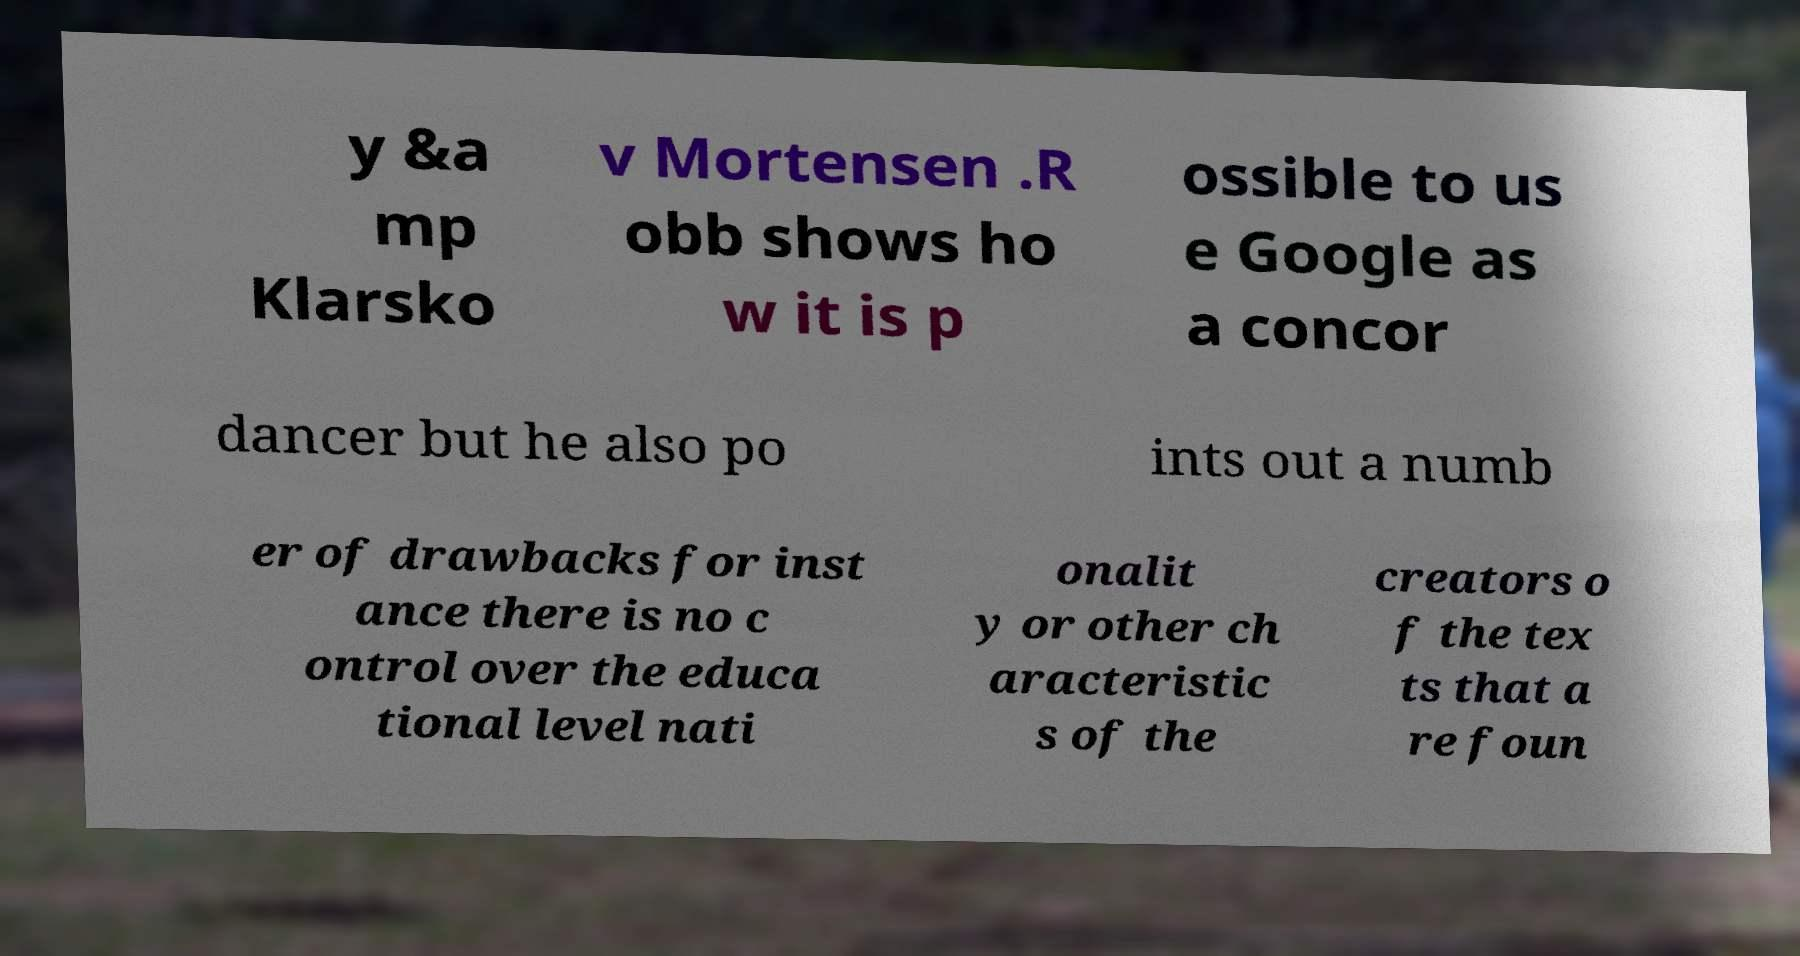Please read and relay the text visible in this image. What does it say? y &a mp Klarsko v Mortensen .R obb shows ho w it is p ossible to us e Google as a concor dancer but he also po ints out a numb er of drawbacks for inst ance there is no c ontrol over the educa tional level nati onalit y or other ch aracteristic s of the creators o f the tex ts that a re foun 